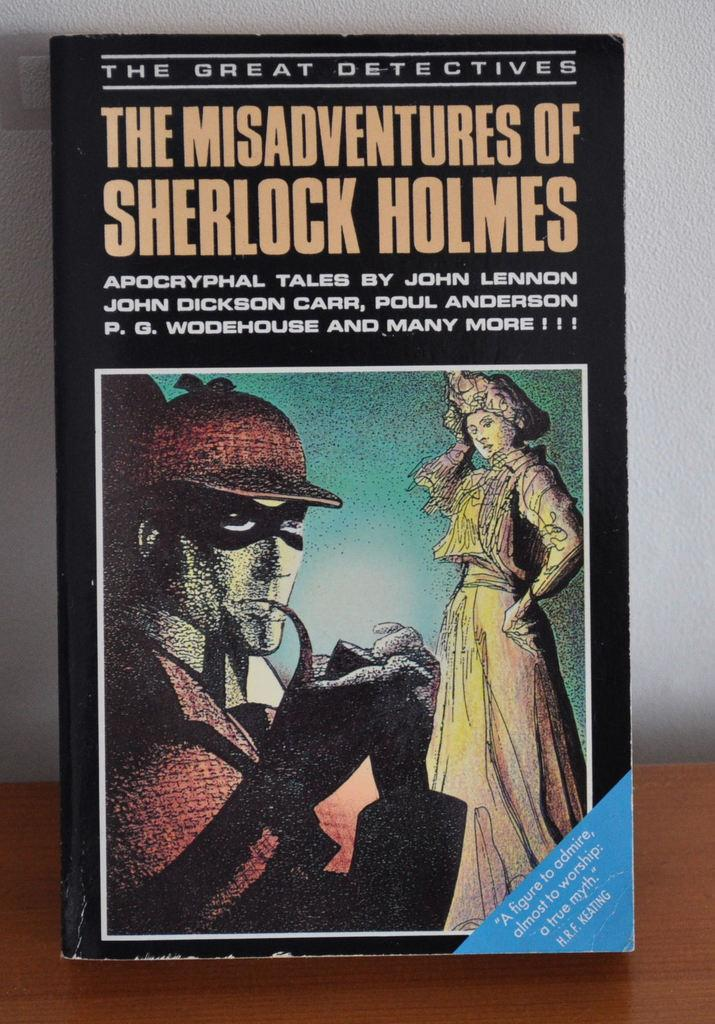<image>
Present a compact description of the photo's key features. A book cover shown about Sherlock Holmes by multiple authors. 